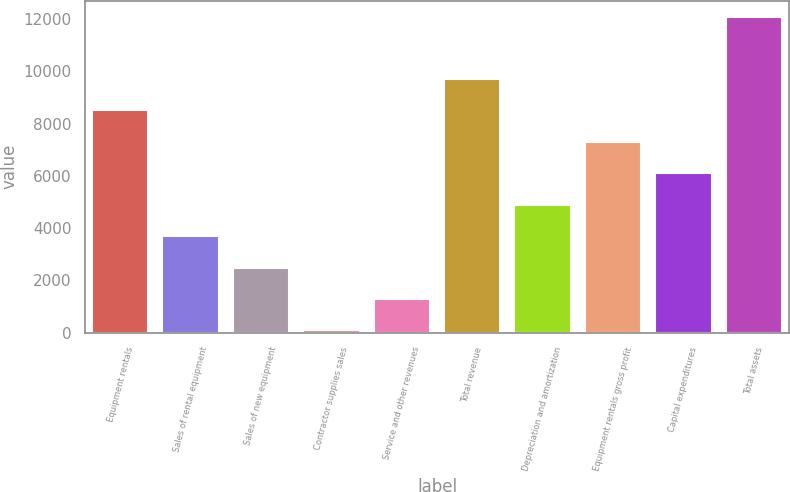<chart> <loc_0><loc_0><loc_500><loc_500><bar_chart><fcel>Equipment rentals<fcel>Sales of rental equipment<fcel>Sales of new equipment<fcel>Contractor supplies sales<fcel>Service and other revenues<fcel>Total revenue<fcel>Depreciation and amortization<fcel>Equipment rentals gross profit<fcel>Capital expenditures<fcel>Total assets<nl><fcel>8514<fcel>3694<fcel>2489<fcel>79<fcel>1284<fcel>9719<fcel>4899<fcel>7309<fcel>6104<fcel>12083<nl></chart> 